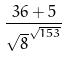Convert formula to latex. <formula><loc_0><loc_0><loc_500><loc_500>\frac { 3 6 + 5 } { \sqrt { 8 } ^ { \sqrt { 1 5 3 } } }</formula> 